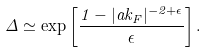Convert formula to latex. <formula><loc_0><loc_0><loc_500><loc_500>\Delta \simeq \exp \left [ \frac { 1 - | a k _ { F } | ^ { - 2 + \epsilon } } { \epsilon } \right ] .</formula> 